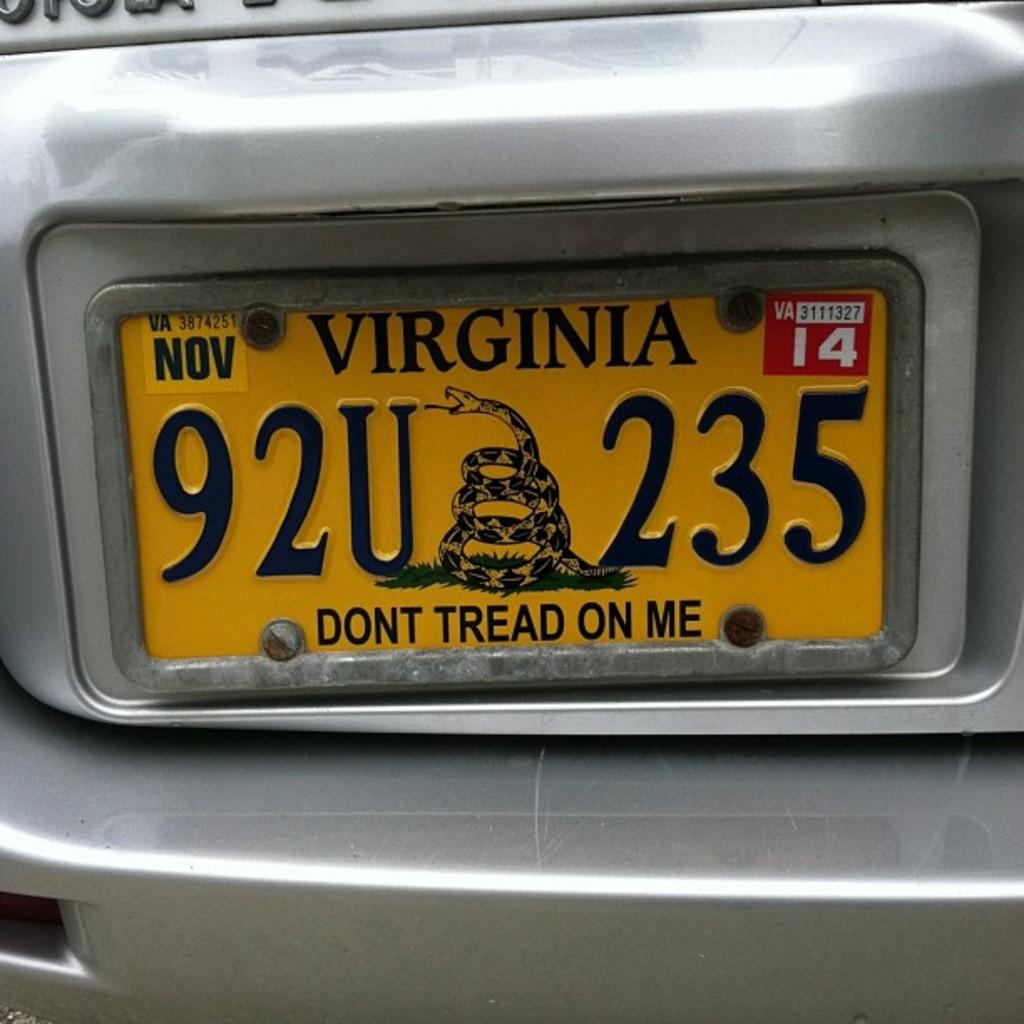<image>
Create a compact narrative representing the image presented. A Virginia license plate with a plate number of 92U235. 